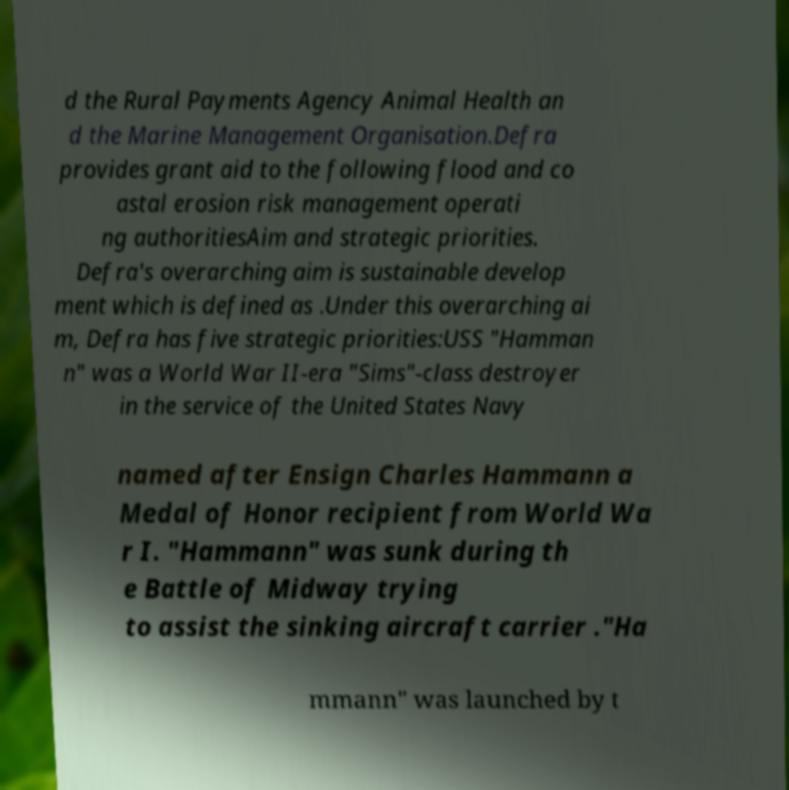For documentation purposes, I need the text within this image transcribed. Could you provide that? d the Rural Payments Agency Animal Health an d the Marine Management Organisation.Defra provides grant aid to the following flood and co astal erosion risk management operati ng authoritiesAim and strategic priorities. Defra's overarching aim is sustainable develop ment which is defined as .Under this overarching ai m, Defra has five strategic priorities:USS "Hamman n" was a World War II-era "Sims"-class destroyer in the service of the United States Navy named after Ensign Charles Hammann a Medal of Honor recipient from World Wa r I. "Hammann" was sunk during th e Battle of Midway trying to assist the sinking aircraft carrier ."Ha mmann" was launched by t 